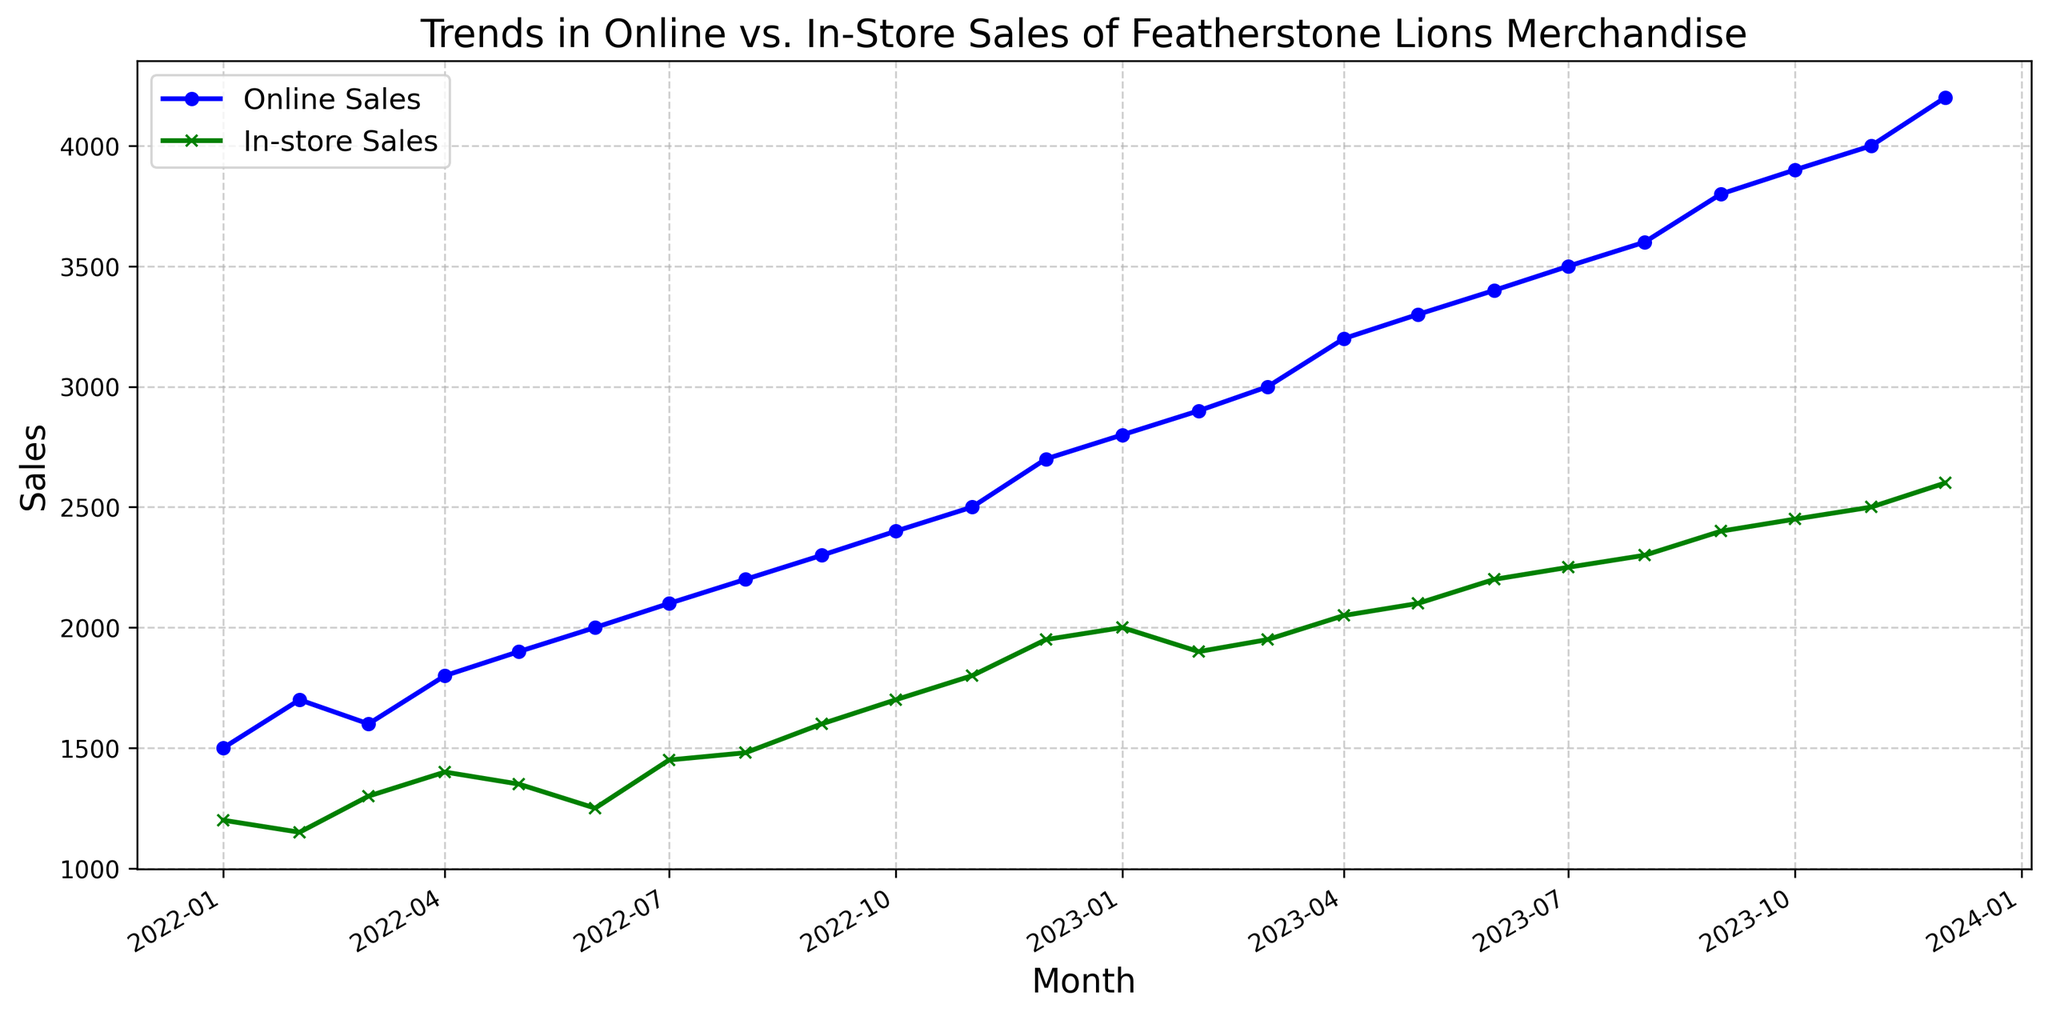what is the difference between Online Sales and In-store Sales in January 2023? In January 2023, Online Sales are 2800 units, and In-store Sales are 2000 units. The difference is calculated by subtracting In-store Sales from Online Sales: 2800 - 2000 = 800.
Answer: 800 In which month did Online Sales first exceed 3000 units? By examining the plot, Online Sales first exceeded 3000 units in March 2023, where the data point shows 3000 units.
Answer: March 2023 What is the average Online Sales from January 2022 to December 2022? To find the average, sum the Online Sales from January 2022 to December 2022: 1500 + 1700 + 1600 + 1800 + 1900 + 2000 + 2100 + 2200 + 2300 + 2400 + 2500 + 2700 = 25700. Dividing by the number of months (12), the average is 25700 / 12 = 2141.67.
Answer: 2141.67 How did In-store Sales change from December 2022 to January 2023? In December 2022, In-store Sales were 1950, and in January 2023, they were 2000. The change is calculated by subtracting December 2022 sales from January 2023 sales: 2000 - 1950 = 50. So, In-store Sales increased by 50 units.
Answer: Increased by 50 Which month had the smallest gap between Online Sales and In-store Sales? By observing the plot, the smallest gap appears to be in October 2022, where Online Sales were 2400 units, and In-store Sales were 1700 units, making the gap 2400 - 1700 = 700.
Answer: October 2022 What is the overall trend in Online Sales from January 2022 to December 2023? By examining the plot, we see a consistent upward trend in Online Sales from January 2022 (1500 units) to December 2023 (4200 units).
Answer: Upward trend Compare the percentage increase in Online Sales and In-store Sales from January 2022 to December 2023. To find the percentage increase: Online Sales increased from 1500 to 4200, which is ((4200 - 1500) / 1500) * 100 = 180%. In-store Sales increased from 1200 to 2600, which is ((2600 - 1200) / 1200) * 100 = 116.67%.
Answer: Online: 180%, In-store: 116.67% When did In-store Sales reach 2000 units? According to the plot, In-store Sales reached 2000 units in January 2023.
Answer: January 2023 